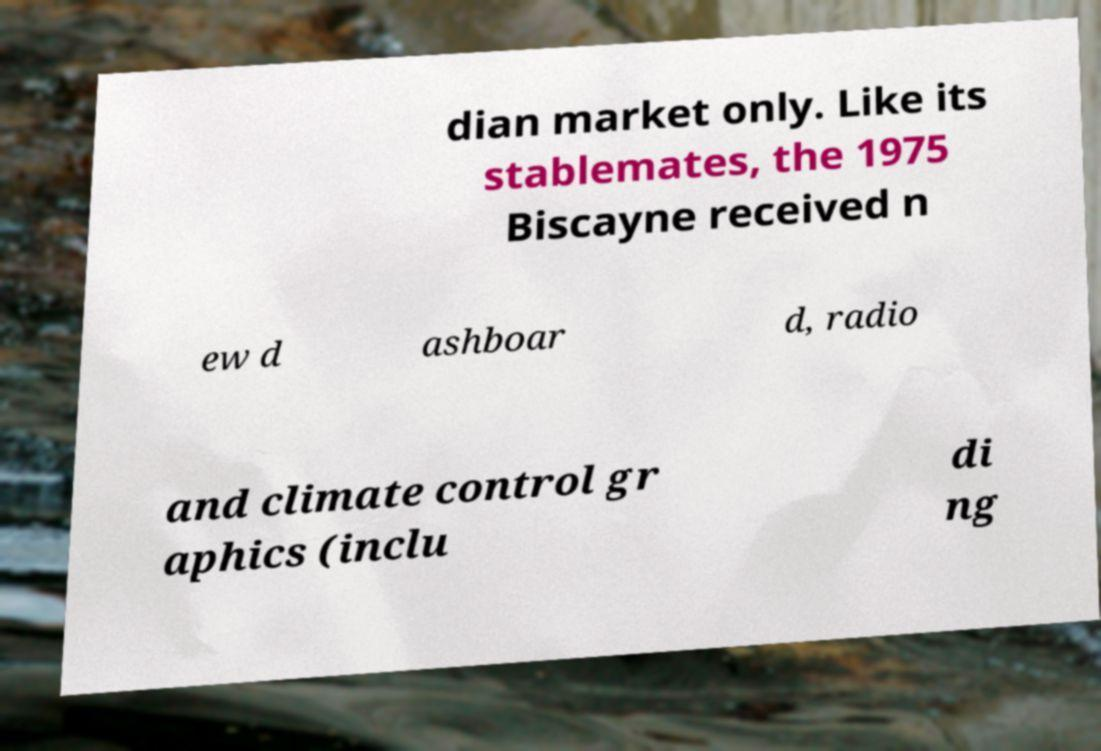Can you accurately transcribe the text from the provided image for me? dian market only. Like its stablemates, the 1975 Biscayne received n ew d ashboar d, radio and climate control gr aphics (inclu di ng 